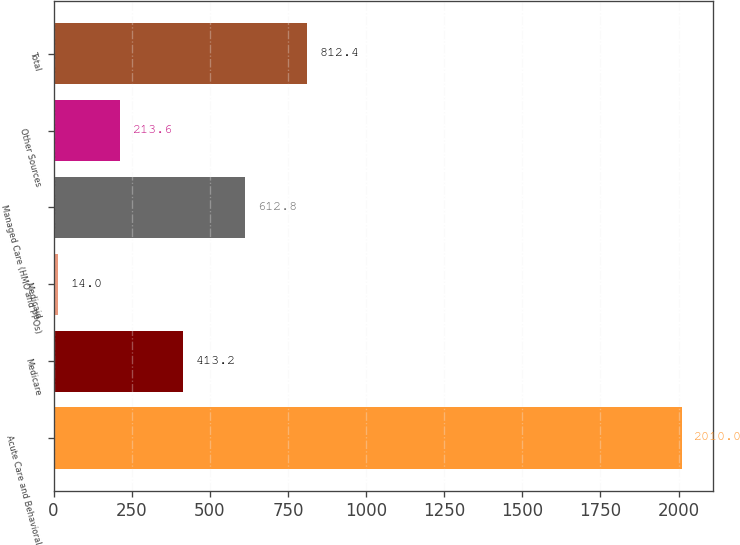Convert chart to OTSL. <chart><loc_0><loc_0><loc_500><loc_500><bar_chart><fcel>Acute Care and Behavioral<fcel>Medicare<fcel>Medicaid<fcel>Managed Care (HMO and PPOs)<fcel>Other Sources<fcel>Total<nl><fcel>2010<fcel>413.2<fcel>14<fcel>612.8<fcel>213.6<fcel>812.4<nl></chart> 